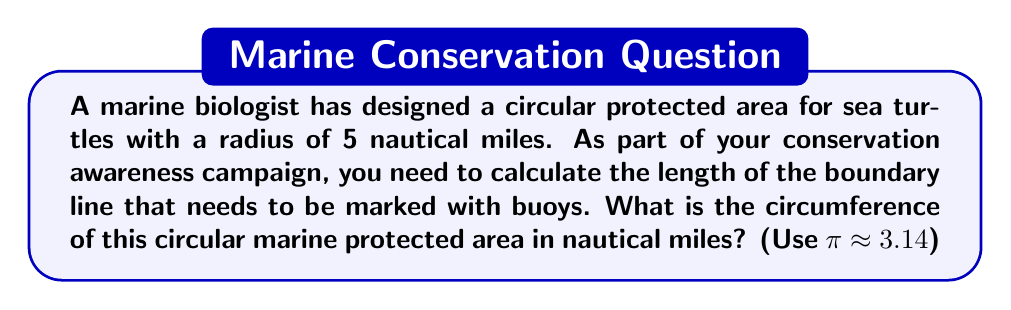Can you answer this question? Let's approach this step-by-step:

1) The formula for the circumference of a circle is:

   $$C = 2πr$$

   Where:
   $C$ = circumference
   $π$ = pi (approximately 3.14)
   $r$ = radius

2) We are given that the radius is 5 nautical miles, so let's substitute the values:

   $$C = 2 * 3.14 * 5$$

3) Let's calculate:

   $$C = 6.28 * 5 = 31.4$$

4) Therefore, the circumference of the circular marine protected area is 31.4 nautical miles.

This result means that you would need to place buoys along a boundary line that is 31.4 nautical miles long to mark the entire protected area for sea turtles.
Answer: 31.4 nautical miles 